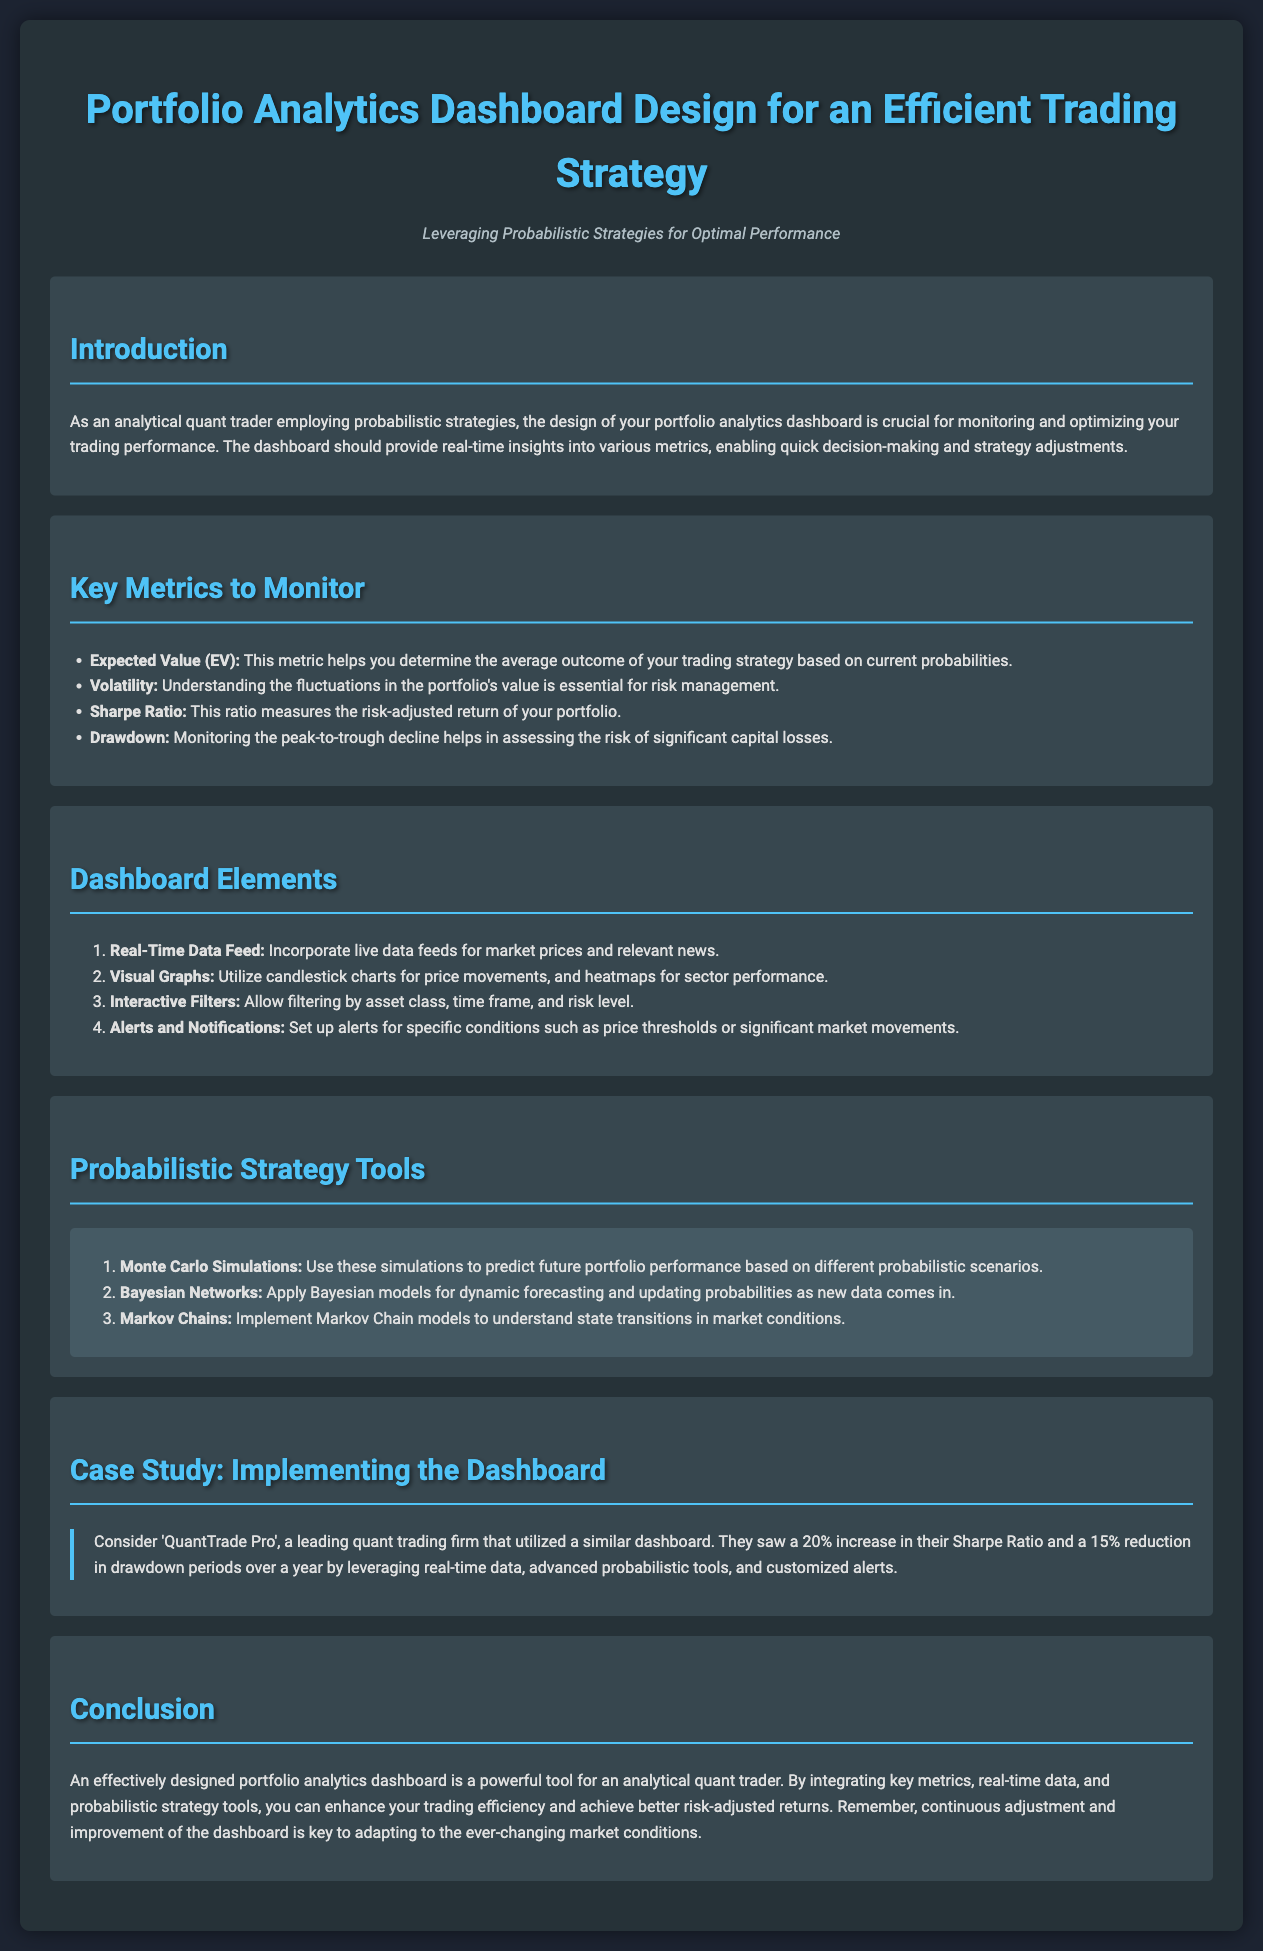what is the title of the document? The title of the document is provided at the top of the rendered document in a prominent format.
Answer: Portfolio Analytics Dashboard Design for an Efficient Trading Strategy what is the subtitle of the document? The subtitle gives an overview of the document's focus and is also prominently displayed.
Answer: Leveraging Probabilistic Strategies for Optimal Performance how many key metrics are suggested to monitor? The section on key metrics lists several important metrics, and the total can be counted from this list.
Answer: Four what is the first element listed under Dashboard Elements? The elements are presented in an ordered list, making it easy to identify the first one.
Answer: Real-Time Data Feed which probabilistic strategy tool uses simulations? The specific tool that utilizes simulations is highlighted in the section about probabilistic strategies.
Answer: Monte Carlo Simulations what percentage increase in Sharpe Ratio did 'QuantTrade Pro' experience? The case study section provides specific improvements made by the firm, including percentages.
Answer: 20% what does the Sharpe Ratio measure? The document describes this ratio in the context of measuring portfolio performance.
Answer: Risk-adjusted return what is one main benefit of an effectively designed dashboard? The conclusion discusses essential advantages of their use for traders.
Answer: Enhance trading efficiency 